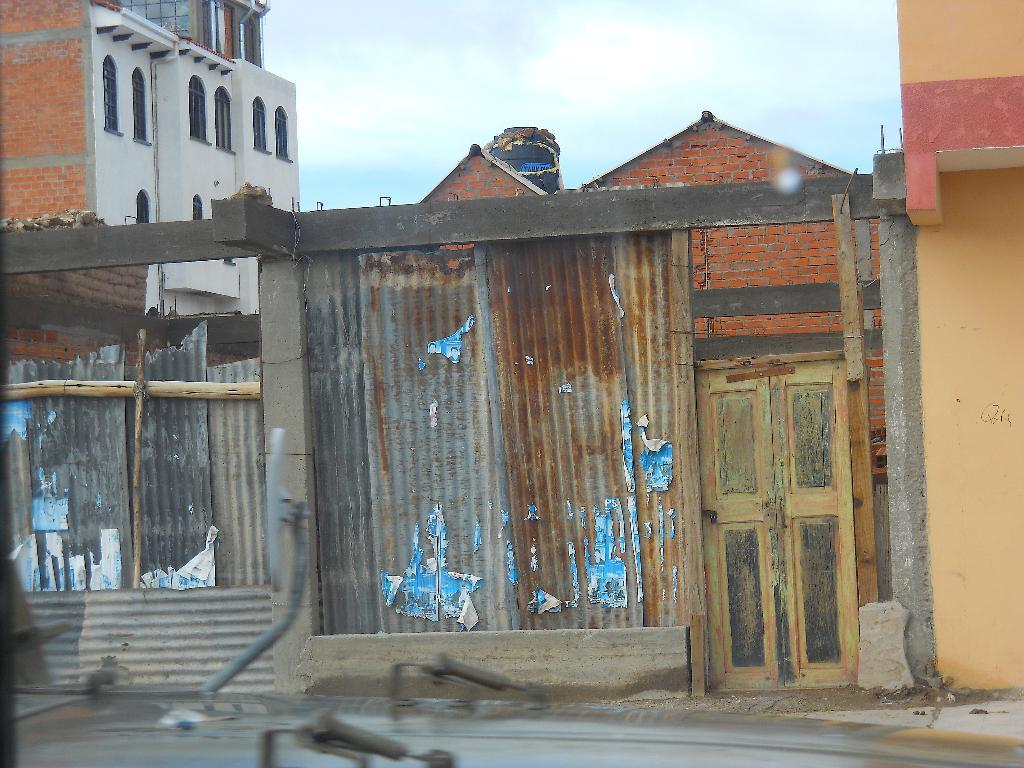Can you describe this image briefly? As we can see in the image that a metal gate. After that a building which is having a brick wall and windows and above the metal sheet their is a sky which is in pale blue color. 